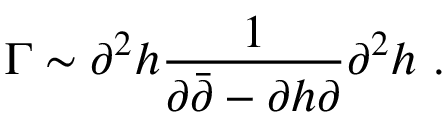Convert formula to latex. <formula><loc_0><loc_0><loc_500><loc_500>\Gamma \sim \partial ^ { 2 } h \frac { 1 } { \partial \bar { \partial } - \partial h \partial } \partial ^ { 2 } h \ .</formula> 